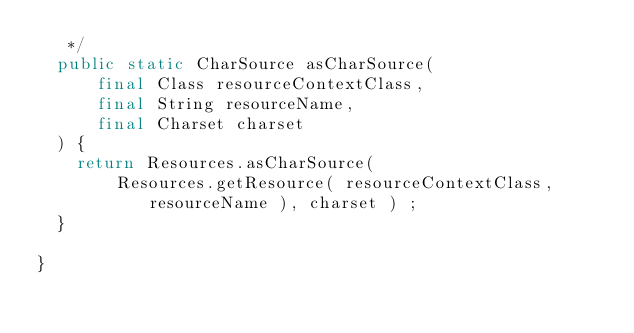<code> <loc_0><loc_0><loc_500><loc_500><_Java_>   */
  public static CharSource asCharSource(
      final Class resourceContextClass,
      final String resourceName,
      final Charset charset
  ) {
    return Resources.asCharSource(
        Resources.getResource( resourceContextClass, resourceName ), charset ) ;
  }

}
</code> 